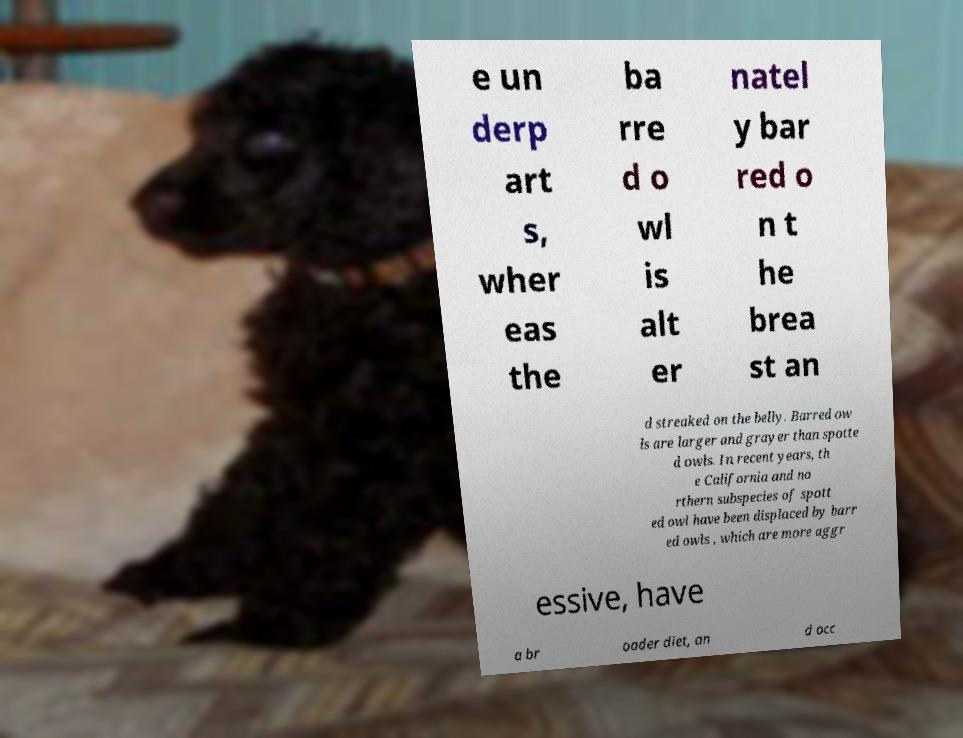Please identify and transcribe the text found in this image. e un derp art s, wher eas the ba rre d o wl is alt er natel y bar red o n t he brea st an d streaked on the belly. Barred ow ls are larger and grayer than spotte d owls. In recent years, th e California and no rthern subspecies of spott ed owl have been displaced by barr ed owls , which are more aggr essive, have a br oader diet, an d occ 